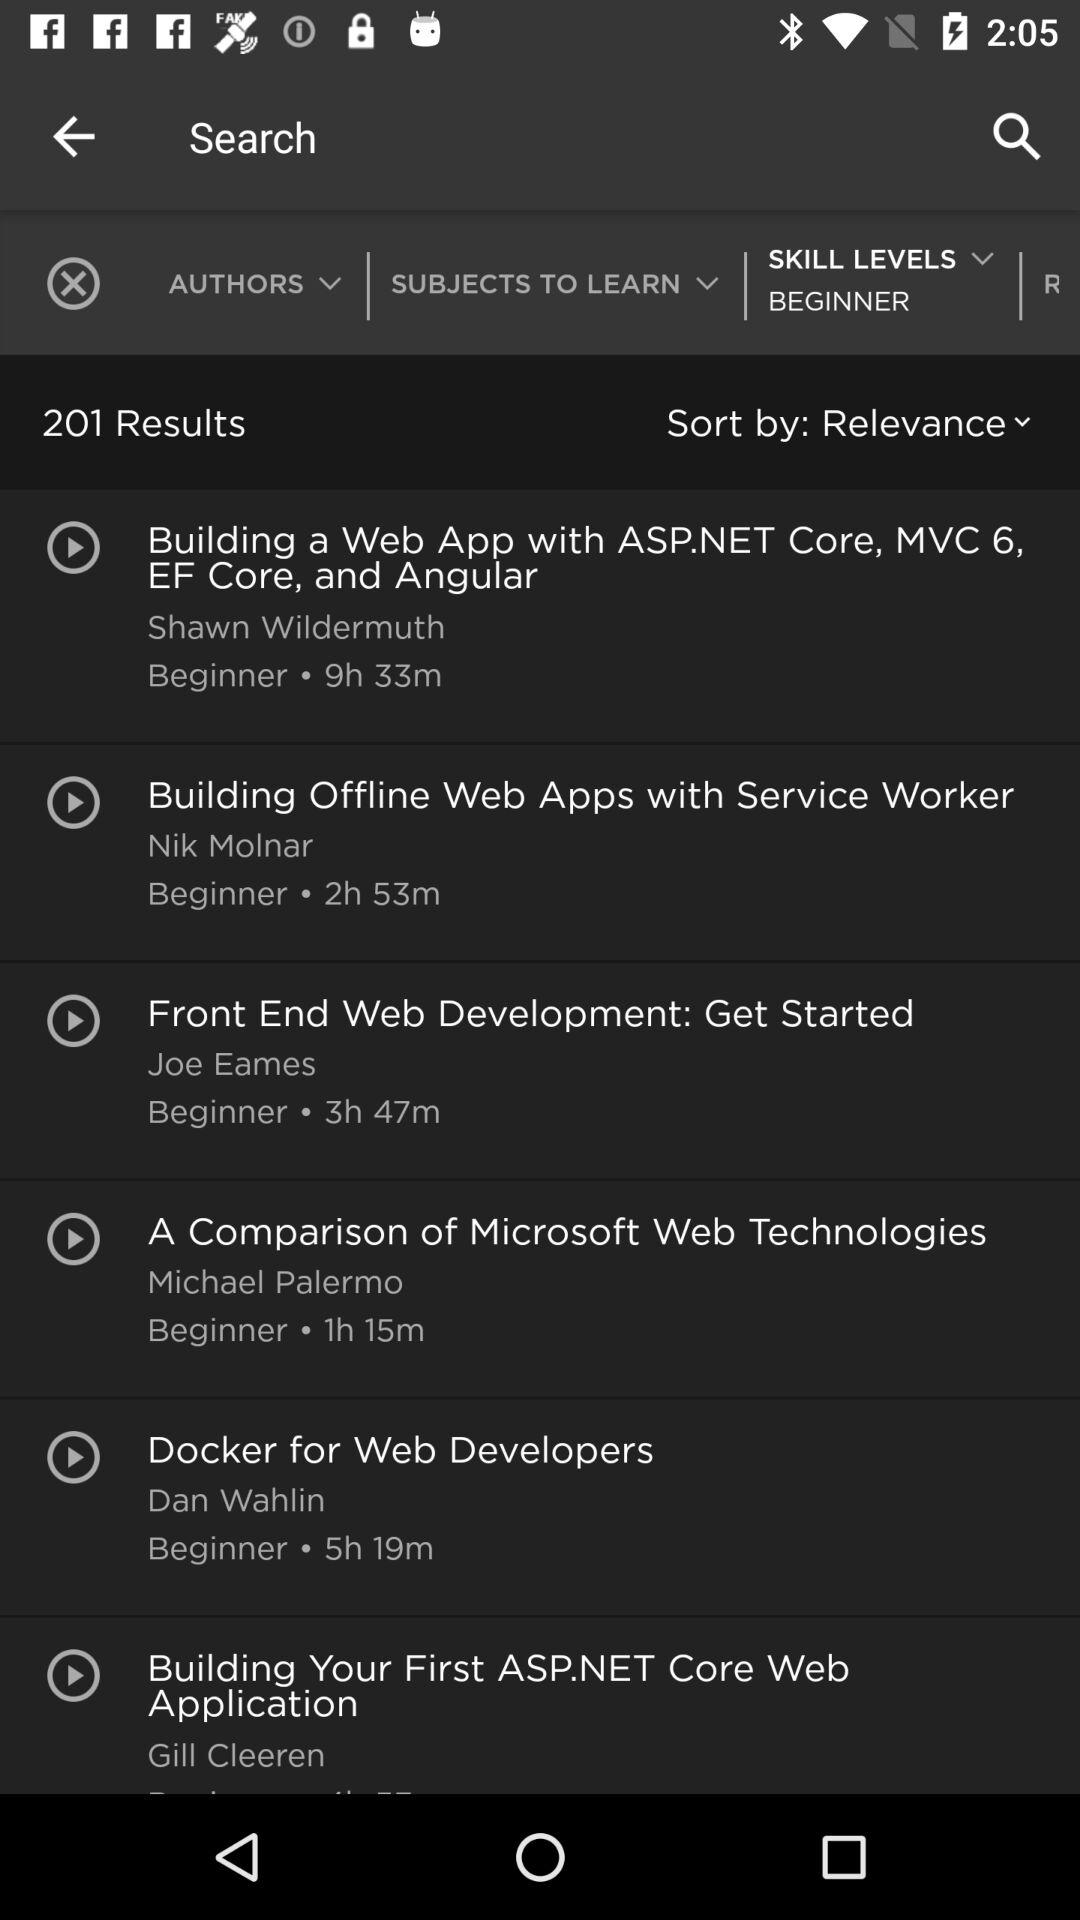Which option is selected in the search menu?
When the provided information is insufficient, respond with <no answer>. <no answer> 